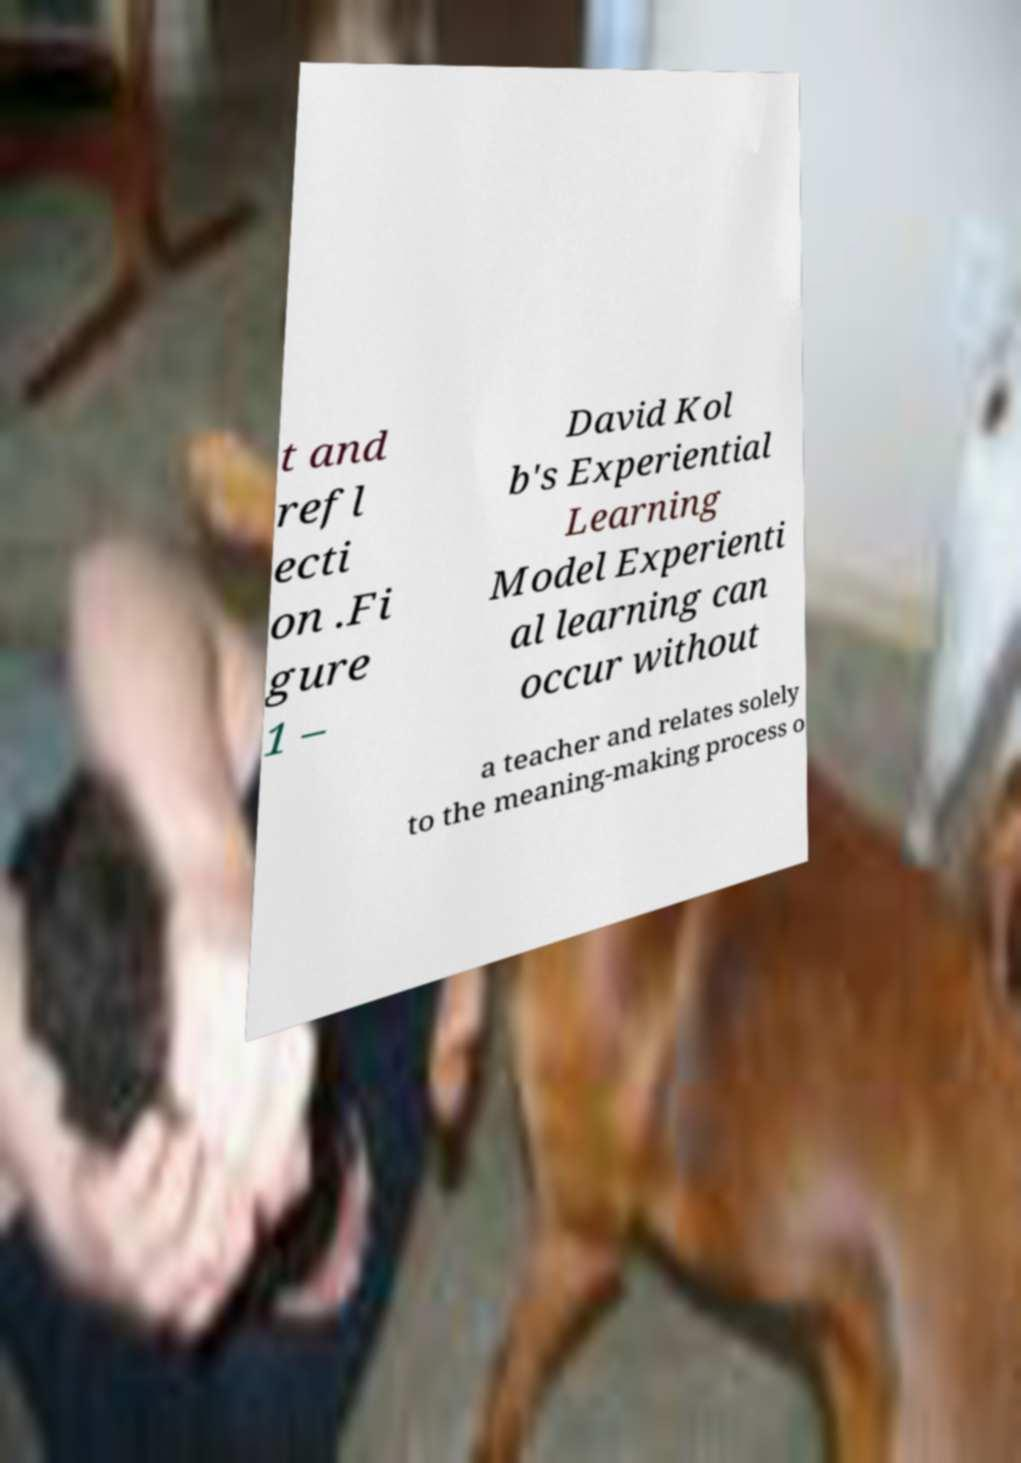Could you assist in decoding the text presented in this image and type it out clearly? t and refl ecti on .Fi gure 1 – David Kol b's Experiential Learning Model Experienti al learning can occur without a teacher and relates solely to the meaning-making process o 